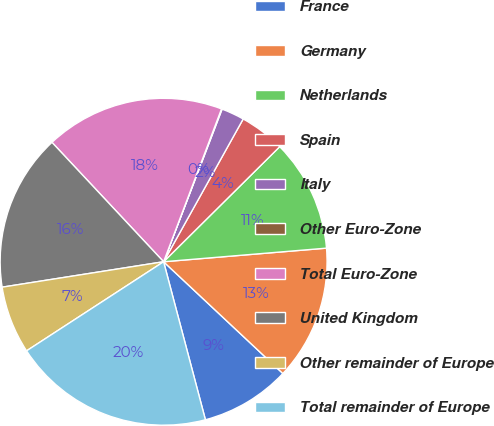<chart> <loc_0><loc_0><loc_500><loc_500><pie_chart><fcel>France<fcel>Germany<fcel>Netherlands<fcel>Spain<fcel>Italy<fcel>Other Euro-Zone<fcel>Total Euro-Zone<fcel>United Kingdom<fcel>Other remainder of Europe<fcel>Total remainder of Europe<nl><fcel>8.9%<fcel>13.31%<fcel>11.1%<fcel>4.48%<fcel>2.27%<fcel>0.06%<fcel>17.73%<fcel>15.52%<fcel>6.69%<fcel>19.94%<nl></chart> 